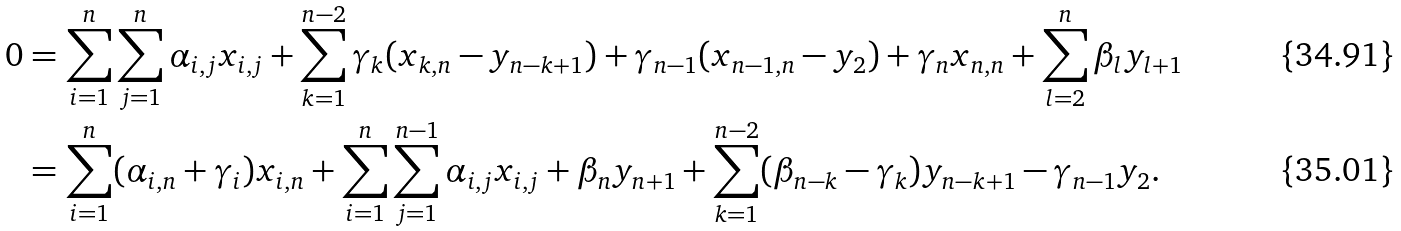<formula> <loc_0><loc_0><loc_500><loc_500>0 & = \sum _ { i = 1 } ^ { n } \sum _ { j = 1 } ^ { n } \alpha _ { i , j } x _ { i , j } + \sum _ { k = 1 } ^ { n - 2 } \gamma _ { k } ( x _ { k , n } - y _ { n - k + 1 } ) + \gamma _ { n - 1 } ( x _ { n - 1 , n } - y _ { 2 } ) + \gamma _ { n } x _ { n , n } + \sum _ { l = 2 } ^ { n } \beta _ { l } y _ { l + 1 } \\ & = \sum _ { i = 1 } ^ { n } ( \alpha _ { i , n } + \gamma _ { i } ) x _ { i , n } + \sum _ { i = 1 } ^ { n } \sum _ { j = 1 } ^ { n - 1 } \alpha _ { i , j } x _ { i , j } + \beta _ { n } y _ { n + 1 } + \sum _ { k = 1 } ^ { n - 2 } ( \beta _ { n - k } - \gamma _ { k } ) y _ { n - k + 1 } - \gamma _ { n - 1 } y _ { 2 } .</formula> 